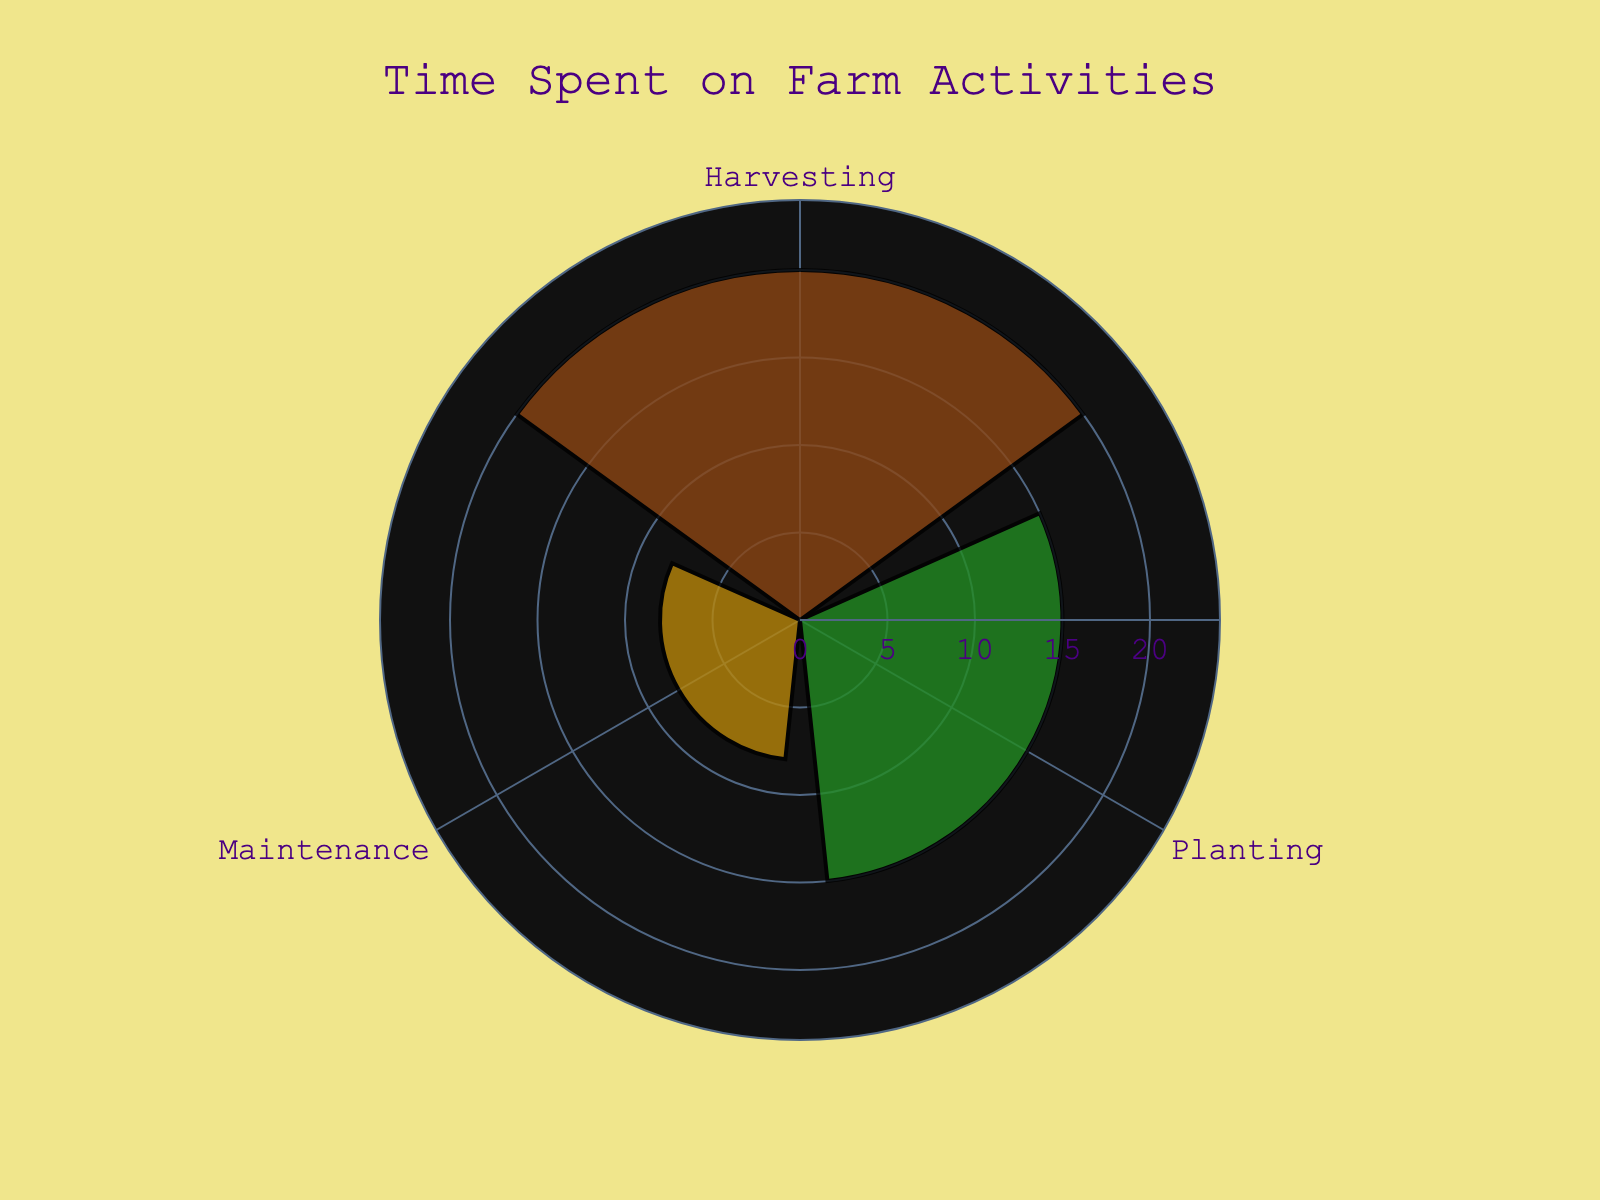what is the main title of the figure? The main title is displayed at the top center of the figure. It says "Time Spent on Farm Activities".
Answer: Time Spent on Farm Activities Which activity has the highest time spent? The figure displays bars in a polar layout, and the activity with the longest bar represents the highest time spent. This is Harvesting.
Answer: Harvesting What is the range of the radial axis? The radial axis range can be identified by looking at the scale around the edge of the rose chart. It spans from 0 to a value slightly above the highest value, which is around 24 hours (20 * 1.2).
Answer: 0 to 24 hours List the activities included in the plot. The activities included in the plot are displayed as categories along the angular axis of the rose chart. They are Planting, Harvesting, and Maintenance.
Answer: Planting, Harvesting, Maintenance How much more time is spent on Harvesting compared to Maintenance? To find this, look at the length of the bars for Harvesting and Maintenance. Harvesting is 20 hours and Maintenance is 8 hours. The difference is calculated as 20 - 8 = 12 hours.
Answer: 12 hours Which activity has the least time spent? By looking at the shortest bar in the rose chart, you can identify the activity with the least amount of time spent out of the top 3 activities. This is Maintenance.
Answer: Maintenance What is the total time spent on Planting and Harvesting? Sum the time spent on Planting and Harvesting. Planting is 15 hours and Harvesting is 20 hours. The total is 15 + 20 = 35 hours.
Answer: 35 hours What color represents the Harvesting activity? The figure uses specific colors for each activity, which can be identified. Harvesting is represented by the color green.
Answer: green How is the time divided among the displayed activities? The figure shows the time spent on each of the activities via bar lengths. Planting: 15 hours, Harvesting: 20 hours, Maintenance: 8 hours.
Answer: Planting: 15 hours, Harvesting: 20 hours, Maintenance: 8 hours 